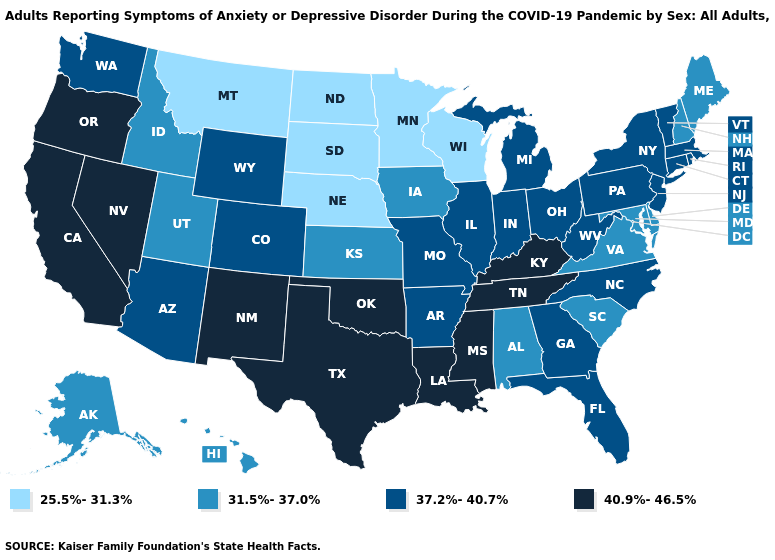Name the states that have a value in the range 25.5%-31.3%?
Give a very brief answer. Minnesota, Montana, Nebraska, North Dakota, South Dakota, Wisconsin. Does Illinois have the highest value in the MidWest?
Answer briefly. Yes. Does the map have missing data?
Give a very brief answer. No. What is the highest value in the West ?
Keep it brief. 40.9%-46.5%. Name the states that have a value in the range 37.2%-40.7%?
Concise answer only. Arizona, Arkansas, Colorado, Connecticut, Florida, Georgia, Illinois, Indiana, Massachusetts, Michigan, Missouri, New Jersey, New York, North Carolina, Ohio, Pennsylvania, Rhode Island, Vermont, Washington, West Virginia, Wyoming. What is the value of Florida?
Be succinct. 37.2%-40.7%. What is the value of Montana?
Write a very short answer. 25.5%-31.3%. Name the states that have a value in the range 31.5%-37.0%?
Be succinct. Alabama, Alaska, Delaware, Hawaii, Idaho, Iowa, Kansas, Maine, Maryland, New Hampshire, South Carolina, Utah, Virginia. Name the states that have a value in the range 37.2%-40.7%?
Write a very short answer. Arizona, Arkansas, Colorado, Connecticut, Florida, Georgia, Illinois, Indiana, Massachusetts, Michigan, Missouri, New Jersey, New York, North Carolina, Ohio, Pennsylvania, Rhode Island, Vermont, Washington, West Virginia, Wyoming. Which states have the lowest value in the South?
Be succinct. Alabama, Delaware, Maryland, South Carolina, Virginia. Among the states that border Ohio , does Michigan have the lowest value?
Answer briefly. Yes. What is the lowest value in the West?
Short answer required. 25.5%-31.3%. What is the highest value in the West ?
Be succinct. 40.9%-46.5%. Name the states that have a value in the range 31.5%-37.0%?
Answer briefly. Alabama, Alaska, Delaware, Hawaii, Idaho, Iowa, Kansas, Maine, Maryland, New Hampshire, South Carolina, Utah, Virginia. Does Michigan have the highest value in the USA?
Write a very short answer. No. 